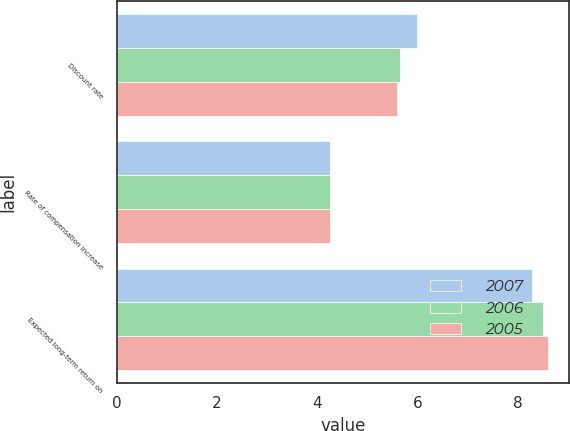Convert chart. <chart><loc_0><loc_0><loc_500><loc_500><stacked_bar_chart><ecel><fcel>Discount rate<fcel>Rate of compensation increase<fcel>Expected long-term return on<nl><fcel>2007<fcel>6<fcel>4.25<fcel>8.3<nl><fcel>2006<fcel>5.65<fcel>4.25<fcel>8.5<nl><fcel>2005<fcel>5.6<fcel>4.25<fcel>8.6<nl></chart> 